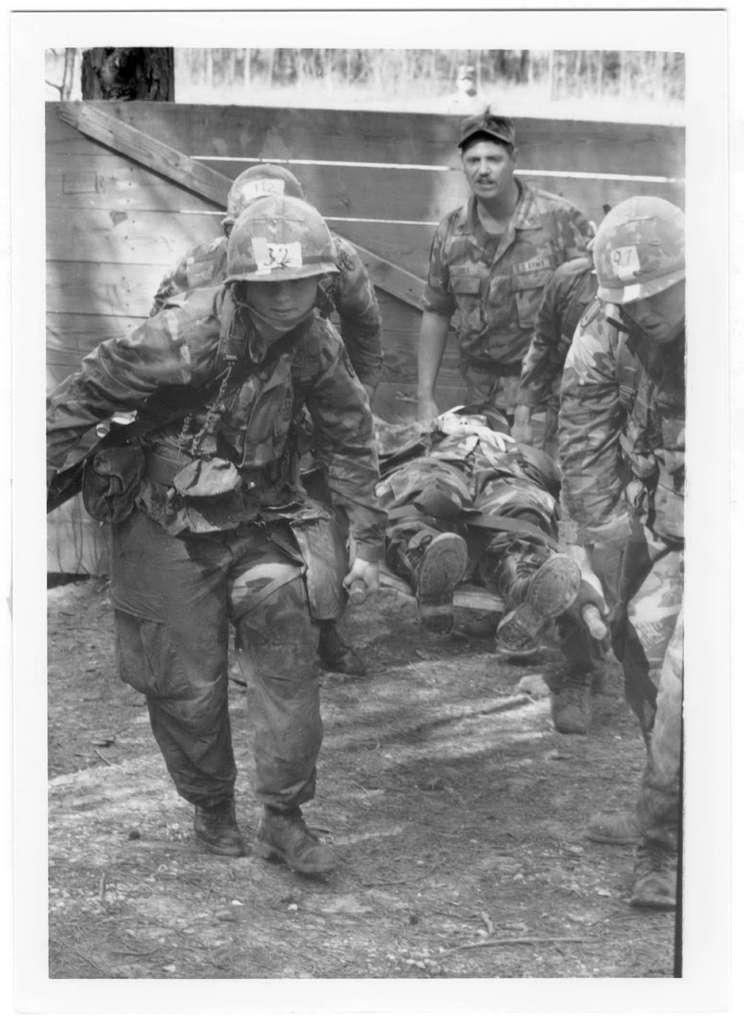What type of people are present in the image? There are soldiers in the image. What are the soldiers doing in the image? The soldiers are carrying an injured soldier. What can be seen in the background of the image? There is a wall in the background of the image. What account number is associated with the injured soldier in the image? There is no account number associated with the injured soldier in the image. 